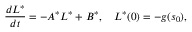<formula> <loc_0><loc_0><loc_500><loc_500>\frac { d L ^ { * } } { d t } = - A ^ { * } L ^ { * } + B ^ { * } , \quad L ^ { * } ( 0 ) = - g ( s _ { 0 } ) ,</formula> 